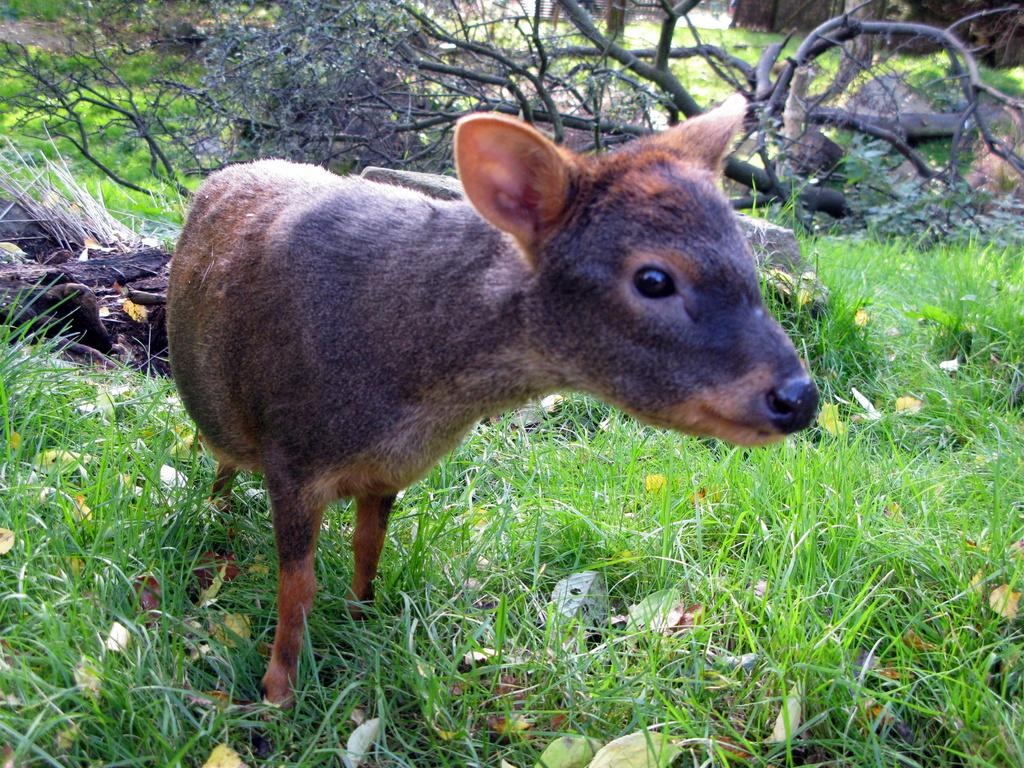What type of animal can be seen on the ground in the image? There is an animal on the ground in the image, but the specific type cannot be determined from the provided facts. What type of terrain is visible at the bottom of the image? There is grass visible at the bottom of the image. What objects can be seen in the background of the image? There are sticks in the background of the image. What type of event is taking place in the image? There is no indication of an event taking place in the image. What type of land is visible in the image? The specific type of land cannot be determined from the provided facts. 